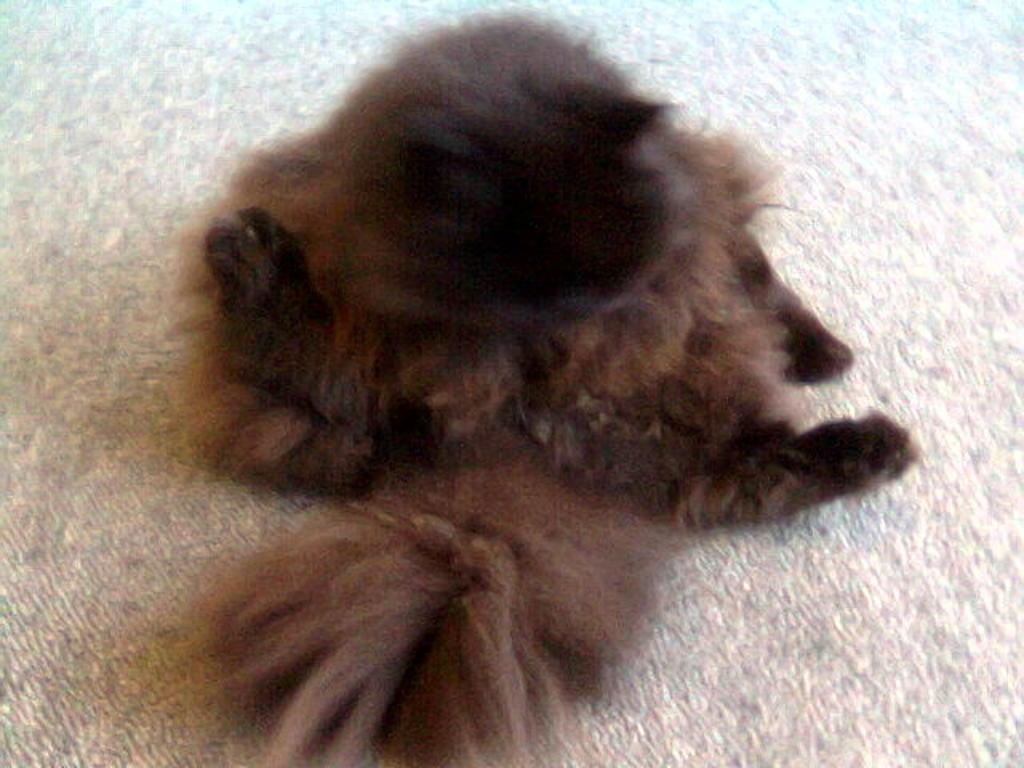What color is the floor in the image? The floor in the image is white. What can be seen on the white floor? There is a brown object on the floor. What type of shock can be seen on the hands of the cook in the image? There is no cook or hands present in the image, and therefore no shock can be observed. 